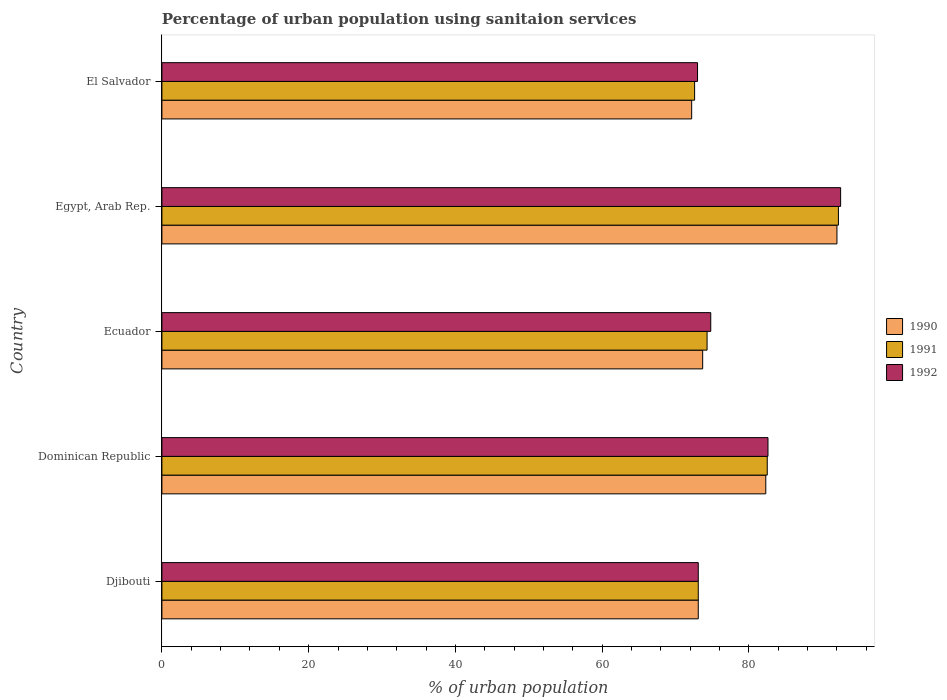How many different coloured bars are there?
Your response must be concise. 3. Are the number of bars on each tick of the Y-axis equal?
Your response must be concise. Yes. What is the label of the 3rd group of bars from the top?
Offer a terse response. Ecuador. What is the percentage of urban population using sanitaion services in 1991 in Ecuador?
Your answer should be very brief. 74.3. Across all countries, what is the maximum percentage of urban population using sanitaion services in 1990?
Offer a very short reply. 92. Across all countries, what is the minimum percentage of urban population using sanitaion services in 1990?
Your answer should be compact. 72.2. In which country was the percentage of urban population using sanitaion services in 1992 maximum?
Keep it short and to the point. Egypt, Arab Rep. In which country was the percentage of urban population using sanitaion services in 1992 minimum?
Make the answer very short. El Salvador. What is the total percentage of urban population using sanitaion services in 1992 in the graph?
Your answer should be compact. 396. What is the difference between the percentage of urban population using sanitaion services in 1992 in Ecuador and that in Egypt, Arab Rep.?
Your response must be concise. -17.7. What is the difference between the percentage of urban population using sanitaion services in 1990 in El Salvador and the percentage of urban population using sanitaion services in 1991 in Ecuador?
Offer a terse response. -2.1. What is the average percentage of urban population using sanitaion services in 1991 per country?
Your answer should be compact. 78.94. What is the difference between the percentage of urban population using sanitaion services in 1991 and percentage of urban population using sanitaion services in 1992 in El Salvador?
Keep it short and to the point. -0.4. What is the ratio of the percentage of urban population using sanitaion services in 1992 in Djibouti to that in Ecuador?
Your answer should be very brief. 0.98. What is the difference between the highest and the second highest percentage of urban population using sanitaion services in 1990?
Offer a terse response. 9.7. What is the difference between the highest and the lowest percentage of urban population using sanitaion services in 1991?
Provide a short and direct response. 19.6. In how many countries, is the percentage of urban population using sanitaion services in 1992 greater than the average percentage of urban population using sanitaion services in 1992 taken over all countries?
Ensure brevity in your answer.  2. What does the 1st bar from the bottom in Dominican Republic represents?
Ensure brevity in your answer.  1990. Is it the case that in every country, the sum of the percentage of urban population using sanitaion services in 1991 and percentage of urban population using sanitaion services in 1992 is greater than the percentage of urban population using sanitaion services in 1990?
Ensure brevity in your answer.  Yes. How many bars are there?
Make the answer very short. 15. Are all the bars in the graph horizontal?
Provide a succinct answer. Yes. What is the difference between two consecutive major ticks on the X-axis?
Provide a succinct answer. 20. Does the graph contain grids?
Provide a short and direct response. No. Where does the legend appear in the graph?
Make the answer very short. Center right. What is the title of the graph?
Your answer should be very brief. Percentage of urban population using sanitaion services. What is the label or title of the X-axis?
Provide a succinct answer. % of urban population. What is the label or title of the Y-axis?
Offer a very short reply. Country. What is the % of urban population of 1990 in Djibouti?
Keep it short and to the point. 73.1. What is the % of urban population in 1991 in Djibouti?
Offer a very short reply. 73.1. What is the % of urban population of 1992 in Djibouti?
Provide a succinct answer. 73.1. What is the % of urban population of 1990 in Dominican Republic?
Offer a terse response. 82.3. What is the % of urban population in 1991 in Dominican Republic?
Provide a succinct answer. 82.5. What is the % of urban population of 1992 in Dominican Republic?
Your response must be concise. 82.6. What is the % of urban population of 1990 in Ecuador?
Provide a short and direct response. 73.7. What is the % of urban population of 1991 in Ecuador?
Your answer should be compact. 74.3. What is the % of urban population in 1992 in Ecuador?
Ensure brevity in your answer.  74.8. What is the % of urban population of 1990 in Egypt, Arab Rep.?
Ensure brevity in your answer.  92. What is the % of urban population in 1991 in Egypt, Arab Rep.?
Offer a very short reply. 92.2. What is the % of urban population of 1992 in Egypt, Arab Rep.?
Make the answer very short. 92.5. What is the % of urban population in 1990 in El Salvador?
Your response must be concise. 72.2. What is the % of urban population of 1991 in El Salvador?
Keep it short and to the point. 72.6. What is the % of urban population of 1992 in El Salvador?
Give a very brief answer. 73. Across all countries, what is the maximum % of urban population in 1990?
Give a very brief answer. 92. Across all countries, what is the maximum % of urban population in 1991?
Give a very brief answer. 92.2. Across all countries, what is the maximum % of urban population of 1992?
Make the answer very short. 92.5. Across all countries, what is the minimum % of urban population in 1990?
Keep it short and to the point. 72.2. Across all countries, what is the minimum % of urban population of 1991?
Your response must be concise. 72.6. Across all countries, what is the minimum % of urban population in 1992?
Offer a terse response. 73. What is the total % of urban population of 1990 in the graph?
Provide a succinct answer. 393.3. What is the total % of urban population of 1991 in the graph?
Provide a short and direct response. 394.7. What is the total % of urban population in 1992 in the graph?
Give a very brief answer. 396. What is the difference between the % of urban population in 1990 in Djibouti and that in Dominican Republic?
Provide a succinct answer. -9.2. What is the difference between the % of urban population of 1991 in Djibouti and that in Dominican Republic?
Offer a very short reply. -9.4. What is the difference between the % of urban population in 1992 in Djibouti and that in Dominican Republic?
Your response must be concise. -9.5. What is the difference between the % of urban population in 1991 in Djibouti and that in Ecuador?
Your answer should be very brief. -1.2. What is the difference between the % of urban population in 1990 in Djibouti and that in Egypt, Arab Rep.?
Your answer should be compact. -18.9. What is the difference between the % of urban population of 1991 in Djibouti and that in Egypt, Arab Rep.?
Your response must be concise. -19.1. What is the difference between the % of urban population in 1992 in Djibouti and that in Egypt, Arab Rep.?
Provide a succinct answer. -19.4. What is the difference between the % of urban population of 1991 in Djibouti and that in El Salvador?
Offer a very short reply. 0.5. What is the difference between the % of urban population in 1992 in Djibouti and that in El Salvador?
Your response must be concise. 0.1. What is the difference between the % of urban population in 1990 in Dominican Republic and that in Ecuador?
Give a very brief answer. 8.6. What is the difference between the % of urban population in 1992 in Dominican Republic and that in Ecuador?
Give a very brief answer. 7.8. What is the difference between the % of urban population of 1991 in Dominican Republic and that in Egypt, Arab Rep.?
Provide a succinct answer. -9.7. What is the difference between the % of urban population of 1990 in Dominican Republic and that in El Salvador?
Your answer should be compact. 10.1. What is the difference between the % of urban population of 1991 in Dominican Republic and that in El Salvador?
Give a very brief answer. 9.9. What is the difference between the % of urban population of 1990 in Ecuador and that in Egypt, Arab Rep.?
Make the answer very short. -18.3. What is the difference between the % of urban population in 1991 in Ecuador and that in Egypt, Arab Rep.?
Your answer should be compact. -17.9. What is the difference between the % of urban population of 1992 in Ecuador and that in Egypt, Arab Rep.?
Your answer should be very brief. -17.7. What is the difference between the % of urban population in 1990 in Ecuador and that in El Salvador?
Ensure brevity in your answer.  1.5. What is the difference between the % of urban population in 1991 in Ecuador and that in El Salvador?
Ensure brevity in your answer.  1.7. What is the difference between the % of urban population in 1990 in Egypt, Arab Rep. and that in El Salvador?
Give a very brief answer. 19.8. What is the difference between the % of urban population of 1991 in Egypt, Arab Rep. and that in El Salvador?
Offer a very short reply. 19.6. What is the difference between the % of urban population of 1992 in Egypt, Arab Rep. and that in El Salvador?
Keep it short and to the point. 19.5. What is the difference between the % of urban population in 1990 in Djibouti and the % of urban population in 1991 in Dominican Republic?
Make the answer very short. -9.4. What is the difference between the % of urban population in 1990 in Djibouti and the % of urban population in 1992 in Dominican Republic?
Your answer should be compact. -9.5. What is the difference between the % of urban population of 1991 in Djibouti and the % of urban population of 1992 in Dominican Republic?
Your answer should be very brief. -9.5. What is the difference between the % of urban population of 1990 in Djibouti and the % of urban population of 1991 in Ecuador?
Ensure brevity in your answer.  -1.2. What is the difference between the % of urban population in 1991 in Djibouti and the % of urban population in 1992 in Ecuador?
Make the answer very short. -1.7. What is the difference between the % of urban population in 1990 in Djibouti and the % of urban population in 1991 in Egypt, Arab Rep.?
Keep it short and to the point. -19.1. What is the difference between the % of urban population of 1990 in Djibouti and the % of urban population of 1992 in Egypt, Arab Rep.?
Offer a terse response. -19.4. What is the difference between the % of urban population in 1991 in Djibouti and the % of urban population in 1992 in Egypt, Arab Rep.?
Ensure brevity in your answer.  -19.4. What is the difference between the % of urban population in 1990 in Djibouti and the % of urban population in 1991 in El Salvador?
Ensure brevity in your answer.  0.5. What is the difference between the % of urban population of 1990 in Dominican Republic and the % of urban population of 1991 in Egypt, Arab Rep.?
Your response must be concise. -9.9. What is the difference between the % of urban population in 1990 in Dominican Republic and the % of urban population in 1992 in Egypt, Arab Rep.?
Your answer should be compact. -10.2. What is the difference between the % of urban population in 1991 in Dominican Republic and the % of urban population in 1992 in Egypt, Arab Rep.?
Keep it short and to the point. -10. What is the difference between the % of urban population of 1990 in Dominican Republic and the % of urban population of 1991 in El Salvador?
Offer a terse response. 9.7. What is the difference between the % of urban population in 1990 in Ecuador and the % of urban population in 1991 in Egypt, Arab Rep.?
Keep it short and to the point. -18.5. What is the difference between the % of urban population in 1990 in Ecuador and the % of urban population in 1992 in Egypt, Arab Rep.?
Give a very brief answer. -18.8. What is the difference between the % of urban population of 1991 in Ecuador and the % of urban population of 1992 in Egypt, Arab Rep.?
Keep it short and to the point. -18.2. What is the difference between the % of urban population in 1990 in Ecuador and the % of urban population in 1992 in El Salvador?
Your response must be concise. 0.7. What is the difference between the % of urban population in 1990 in Egypt, Arab Rep. and the % of urban population in 1991 in El Salvador?
Give a very brief answer. 19.4. What is the difference between the % of urban population of 1991 in Egypt, Arab Rep. and the % of urban population of 1992 in El Salvador?
Offer a very short reply. 19.2. What is the average % of urban population of 1990 per country?
Make the answer very short. 78.66. What is the average % of urban population in 1991 per country?
Your answer should be compact. 78.94. What is the average % of urban population in 1992 per country?
Your response must be concise. 79.2. What is the difference between the % of urban population of 1990 and % of urban population of 1992 in Djibouti?
Your answer should be very brief. 0. What is the difference between the % of urban population of 1990 and % of urban population of 1991 in Dominican Republic?
Make the answer very short. -0.2. What is the difference between the % of urban population of 1990 and % of urban population of 1991 in Ecuador?
Give a very brief answer. -0.6. What is the difference between the % of urban population of 1990 and % of urban population of 1992 in Ecuador?
Your answer should be very brief. -1.1. What is the difference between the % of urban population in 1991 and % of urban population in 1992 in Ecuador?
Ensure brevity in your answer.  -0.5. What is the difference between the % of urban population of 1990 and % of urban population of 1992 in Egypt, Arab Rep.?
Give a very brief answer. -0.5. What is the difference between the % of urban population in 1991 and % of urban population in 1992 in El Salvador?
Provide a succinct answer. -0.4. What is the ratio of the % of urban population of 1990 in Djibouti to that in Dominican Republic?
Your answer should be compact. 0.89. What is the ratio of the % of urban population in 1991 in Djibouti to that in Dominican Republic?
Your response must be concise. 0.89. What is the ratio of the % of urban population in 1992 in Djibouti to that in Dominican Republic?
Offer a very short reply. 0.89. What is the ratio of the % of urban population in 1991 in Djibouti to that in Ecuador?
Make the answer very short. 0.98. What is the ratio of the % of urban population in 1992 in Djibouti to that in Ecuador?
Give a very brief answer. 0.98. What is the ratio of the % of urban population of 1990 in Djibouti to that in Egypt, Arab Rep.?
Give a very brief answer. 0.79. What is the ratio of the % of urban population of 1991 in Djibouti to that in Egypt, Arab Rep.?
Offer a very short reply. 0.79. What is the ratio of the % of urban population of 1992 in Djibouti to that in Egypt, Arab Rep.?
Give a very brief answer. 0.79. What is the ratio of the % of urban population of 1990 in Djibouti to that in El Salvador?
Give a very brief answer. 1.01. What is the ratio of the % of urban population in 1991 in Djibouti to that in El Salvador?
Provide a succinct answer. 1.01. What is the ratio of the % of urban population of 1990 in Dominican Republic to that in Ecuador?
Provide a succinct answer. 1.12. What is the ratio of the % of urban population of 1991 in Dominican Republic to that in Ecuador?
Give a very brief answer. 1.11. What is the ratio of the % of urban population in 1992 in Dominican Republic to that in Ecuador?
Your answer should be very brief. 1.1. What is the ratio of the % of urban population of 1990 in Dominican Republic to that in Egypt, Arab Rep.?
Your answer should be very brief. 0.89. What is the ratio of the % of urban population in 1991 in Dominican Republic to that in Egypt, Arab Rep.?
Provide a succinct answer. 0.89. What is the ratio of the % of urban population of 1992 in Dominican Republic to that in Egypt, Arab Rep.?
Keep it short and to the point. 0.89. What is the ratio of the % of urban population in 1990 in Dominican Republic to that in El Salvador?
Offer a terse response. 1.14. What is the ratio of the % of urban population of 1991 in Dominican Republic to that in El Salvador?
Provide a succinct answer. 1.14. What is the ratio of the % of urban population of 1992 in Dominican Republic to that in El Salvador?
Offer a terse response. 1.13. What is the ratio of the % of urban population of 1990 in Ecuador to that in Egypt, Arab Rep.?
Give a very brief answer. 0.8. What is the ratio of the % of urban population of 1991 in Ecuador to that in Egypt, Arab Rep.?
Offer a very short reply. 0.81. What is the ratio of the % of urban population of 1992 in Ecuador to that in Egypt, Arab Rep.?
Your answer should be compact. 0.81. What is the ratio of the % of urban population in 1990 in Ecuador to that in El Salvador?
Give a very brief answer. 1.02. What is the ratio of the % of urban population in 1991 in Ecuador to that in El Salvador?
Provide a succinct answer. 1.02. What is the ratio of the % of urban population in 1992 in Ecuador to that in El Salvador?
Your response must be concise. 1.02. What is the ratio of the % of urban population in 1990 in Egypt, Arab Rep. to that in El Salvador?
Your response must be concise. 1.27. What is the ratio of the % of urban population in 1991 in Egypt, Arab Rep. to that in El Salvador?
Your answer should be compact. 1.27. What is the ratio of the % of urban population of 1992 in Egypt, Arab Rep. to that in El Salvador?
Make the answer very short. 1.27. What is the difference between the highest and the second highest % of urban population of 1990?
Offer a terse response. 9.7. What is the difference between the highest and the second highest % of urban population of 1992?
Keep it short and to the point. 9.9. What is the difference between the highest and the lowest % of urban population of 1990?
Offer a terse response. 19.8. What is the difference between the highest and the lowest % of urban population of 1991?
Make the answer very short. 19.6. What is the difference between the highest and the lowest % of urban population in 1992?
Give a very brief answer. 19.5. 